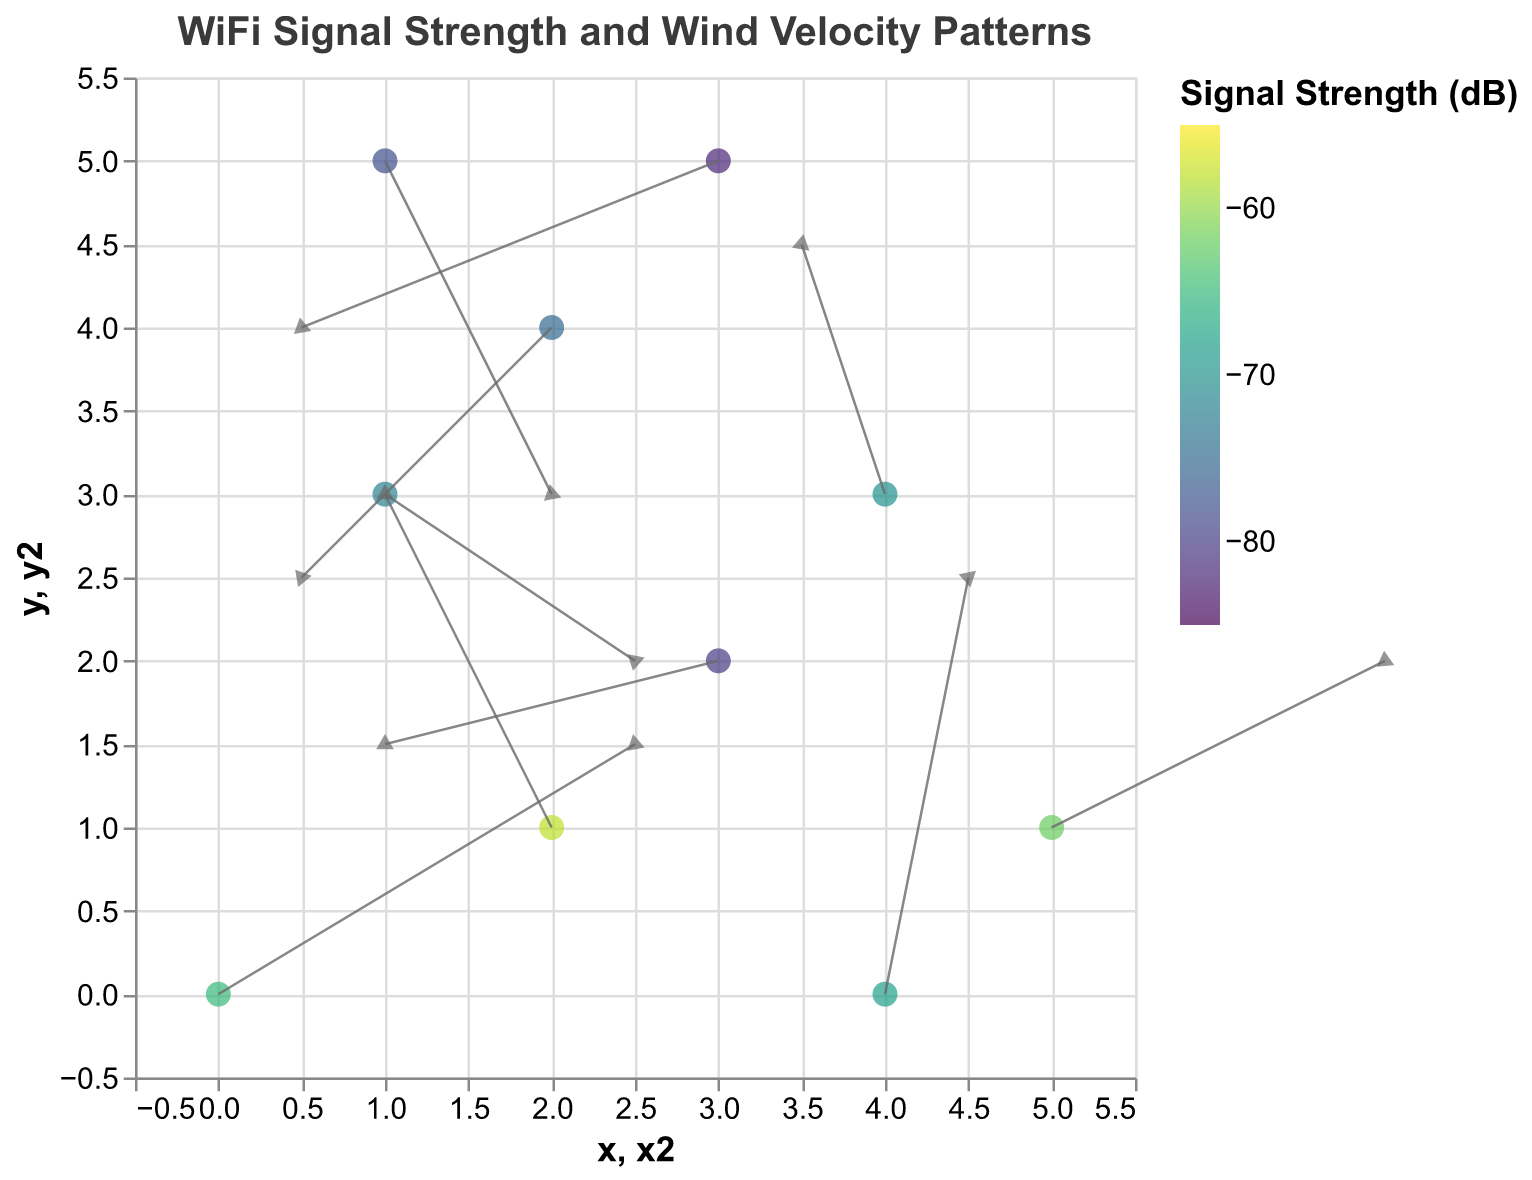What's the title of the plot? The title is usually displayed at the top of the plot. Look at the central text written in larger and darker font.
Answer: "WiFi Signal Strength and Wind Velocity Patterns" How many data points are represented in the plot? Each data point is shown as a dot on the plot. Count all the dots.
Answer: 10 Which data point has the highest signal strength? Identify the dot with the brightest color, which indicates the highest signal strength. Check the legend for the exact color value if necessary. The point with the color closest to -55 dB is the strongest.
Answer: (2, 1) What is the direction and magnitude of wind velocity at (4,0)? Each arrow represents wind velocity. For point (4,0), locate the arrow's direction and use the length to judge the magnitude. The vector (u=1, v=5) implies a direction (right and upwards) and magnitude calculated using the Pythagorean theorem √(1² + 5²).
Answer: Direction: NE, Magnitude: √26 Which data point has the weakest signal strength? Identify the dot with the darkest color, indicating the weakest signal strength. The point with color closest to -85 dB is the weakest.
Answer: (3, 5) At which coordinates is there a wind vector pointing directly downwards? Check for the vectors whose u component is 0 and the v component is negative.
Answer: (1, 5) What is the average signal strength of the three points with the lowest values? Identify the three points with the darkest colors and check their signal strengths. The average is calculated by summing these values and dividing by 3. Summing (-80, -82, -78), then dividing by 3, gives: (-80 + -82 + -78) / 3 = -80
Answer: -80 dB How does the direction of wind impact the signal strength at (3,2) and (1,3)? Compare wind vector directions and the color of dots at these two points. For (3,2), it has strong westward wind and a weak signal of -80 dB. For (1,3), it has northeast wind and a moderate signal of -72 dB, showing strong westward wind blunts signal strength more than varied wind directions.
Answer: (3, 2) shows westward wind and -80 dB, (1, 3) shows northeast wind and -72 dB 